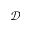<formula> <loc_0><loc_0><loc_500><loc_500>\mathcal { D }</formula> 